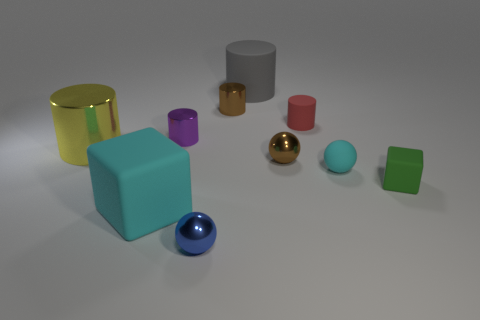Subtract 1 cylinders. How many cylinders are left? 4 Subtract all tiny matte balls. How many balls are left? 2 Subtract all yellow cylinders. How many cylinders are left? 4 Subtract all red cylinders. Subtract all green cubes. How many cylinders are left? 4 Subtract all blocks. How many objects are left? 8 Add 9 cyan cubes. How many cyan cubes exist? 10 Subtract 0 yellow spheres. How many objects are left? 10 Subtract all cyan shiny things. Subtract all small brown shiny things. How many objects are left? 8 Add 5 rubber things. How many rubber things are left? 10 